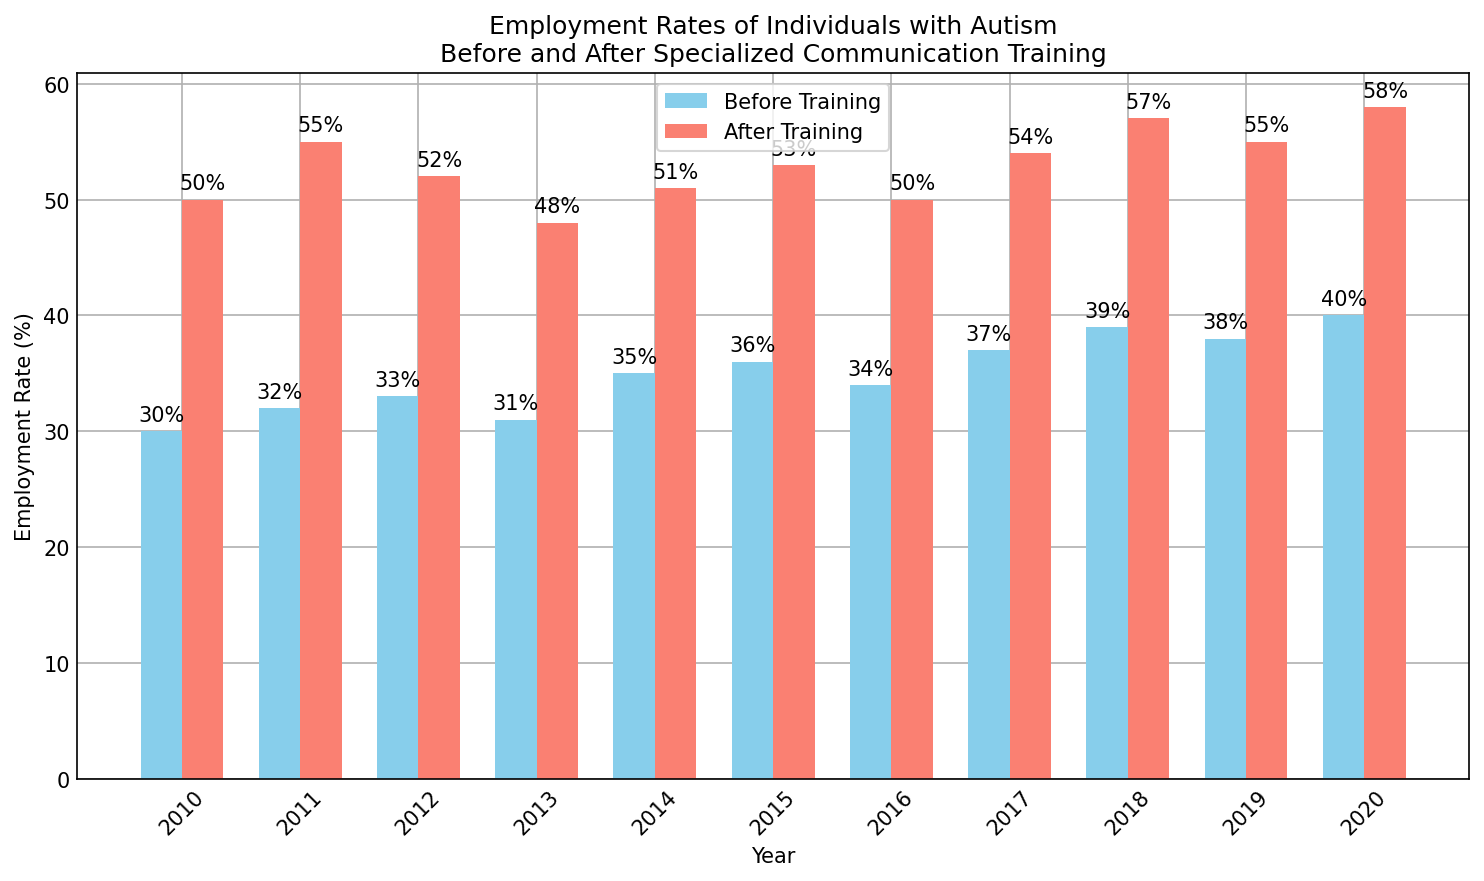What is the highest employment rate before training? The figure shows the employment rates for each year before training. The highest bar represents the highest employment rate. In 2020, the employment rate before training is 40%.
Answer: 40% Compare the employment rates after training between the years 2011 and 2018. Which one is higher? Look at the heights of the bars for 2011 and 2018 that represent employment rates after training. The bar for 2011 (55) is higher than that for 2018 (57). Therefore, 2011 has a higher employment rate after training.
Answer: 2011 What is the average employment rate before training from 2010 to 2020? Sum the employment rates before training for each year from 2010 to 2020 and divide by the number of years: (30 + 32 + 33 + 31 + 35 + 36 + 34 + 37 + 39 + 38 + 40) / 11 ≈ 34.27%.
Answer: 34.27% How did the overall trend of employment rates before and after training change from 2010 to 2020? Visually, observe the trend of the bars representing the years 2010 to 2020. Employment rates before training show a gradual increase, while employment rates after training (negative values) also show an increase (negative).
Answer: Both increased Identify the years where the employment rate before training was less than 35%. The years when the employment rate before training was below 35% are 2010, 2011, 2012, 2013, and 2016. This can be identified by checking all years with bars lower than 35%.
Answer: 2010, 2011, 2012, 2013, 2016 What is the median employment rate before training? To find the median, list all employment rates before training in ascending order (30, 31, 32, 33, 34, 35, 36, 37, 38, 39, 40). The middle value is the sixth one. Therefore, the median rate is 35%.
Answer: 35% Which color represents the employment rate after training? The figure uses color to differentiate between before and after training. Employment rates after training are shown in salmon color.
Answer: Salmon 